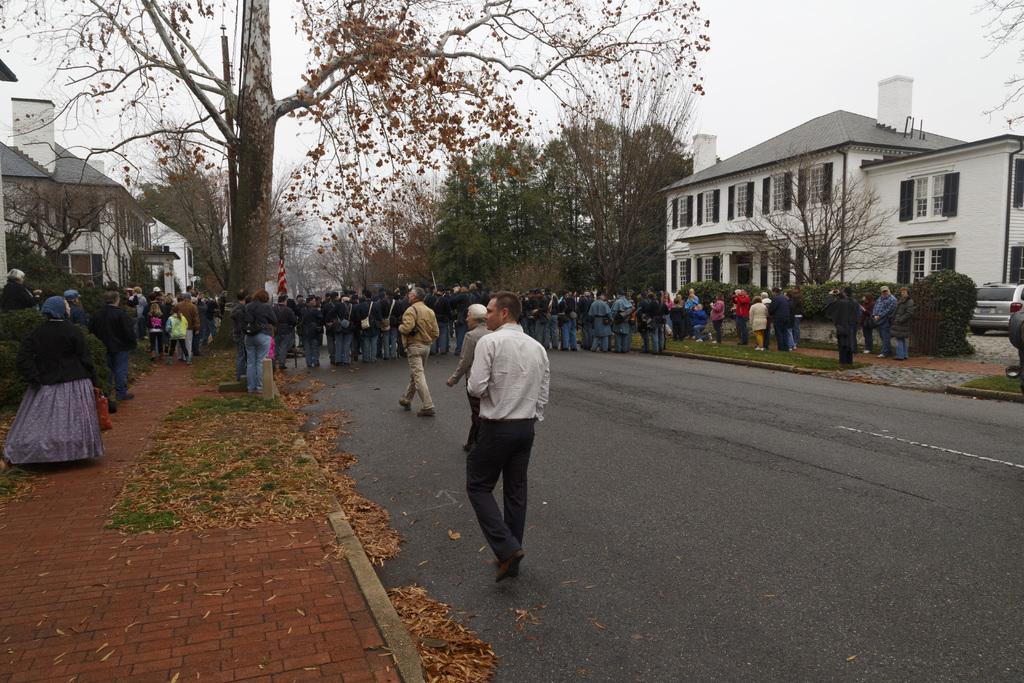Can you describe this image briefly? In the picture we can see a road on it we can see dried leaves and grass and we can see some trees and some people are standing on the path near the houses and on the road also we can see some public are standing from one corner to another corner and on the opposite side we can see a grass surface and some people are standing near it and behind them we can see a house building with windows and pillars to it and beside it we can see some trees and sky behind it. 